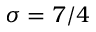Convert formula to latex. <formula><loc_0><loc_0><loc_500><loc_500>\sigma = 7 / 4</formula> 